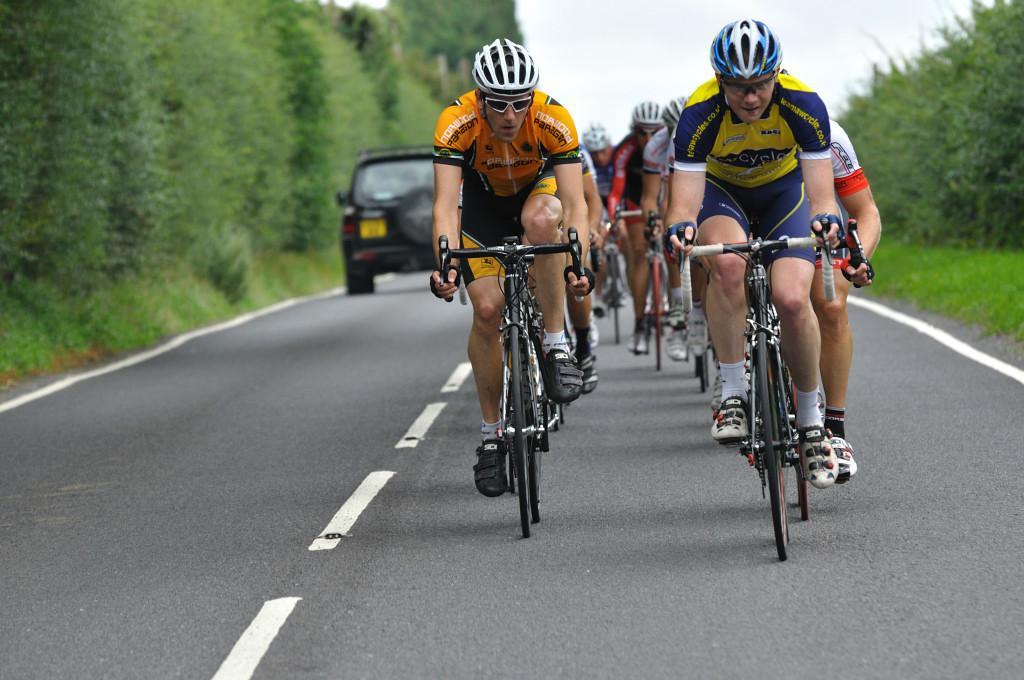How would you summarize this image in a sentence or two? In the image we can see there are many people wearing clothes, goggles, helmet, gloves, socks and shoes, and they are riding on the road with the help of a bicycle. This is a road, white lines on the road and there is even a vehicle. This is a grass, trees and a sky. 